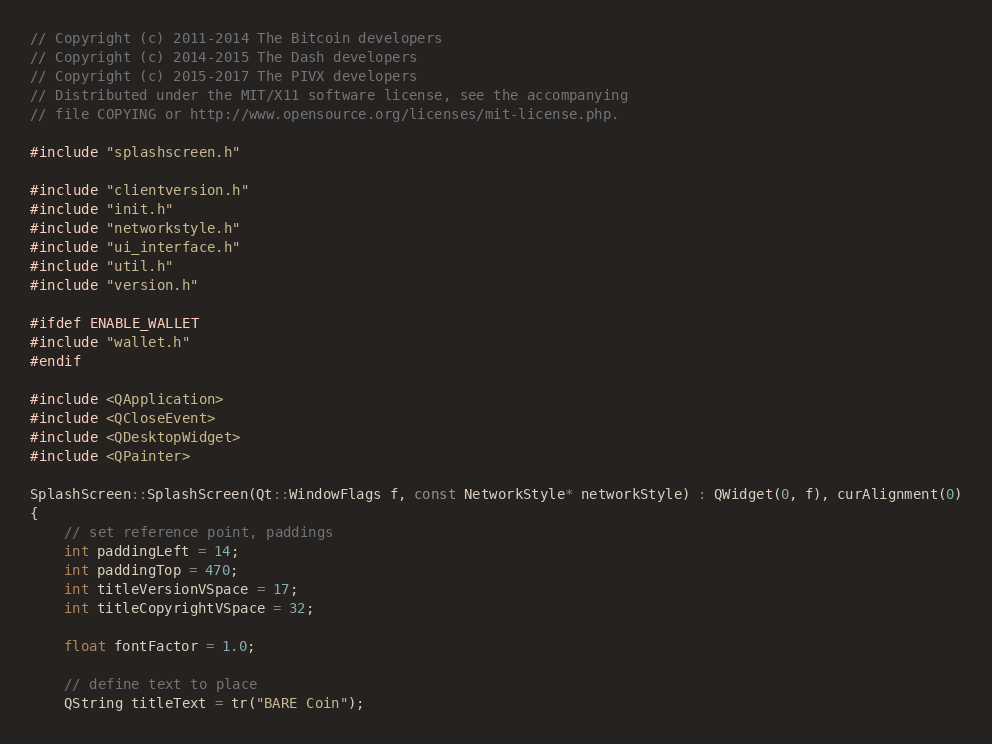Convert code to text. <code><loc_0><loc_0><loc_500><loc_500><_C++_>// Copyright (c) 2011-2014 The Bitcoin developers
// Copyright (c) 2014-2015 The Dash developers
// Copyright (c) 2015-2017 The PIVX developers
// Distributed under the MIT/X11 software license, see the accompanying
// file COPYING or http://www.opensource.org/licenses/mit-license.php.

#include "splashscreen.h"

#include "clientversion.h"
#include "init.h"
#include "networkstyle.h"
#include "ui_interface.h"
#include "util.h"
#include "version.h"

#ifdef ENABLE_WALLET
#include "wallet.h"
#endif

#include <QApplication>
#include <QCloseEvent>
#include <QDesktopWidget>
#include <QPainter>

SplashScreen::SplashScreen(Qt::WindowFlags f, const NetworkStyle* networkStyle) : QWidget(0, f), curAlignment(0)
{
    // set reference point, paddings
    int paddingLeft = 14;
    int paddingTop = 470;
    int titleVersionVSpace = 17;
    int titleCopyrightVSpace = 32;

    float fontFactor = 1.0;

    // define text to place
    QString titleText = tr("BARE Coin");</code> 